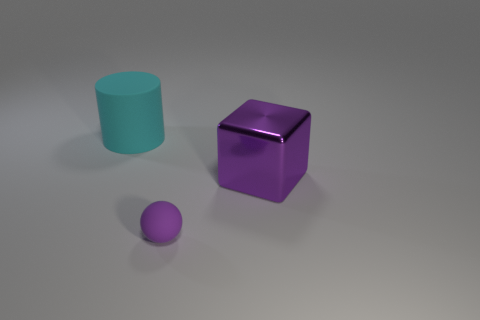Are there any other things that have the same size as the sphere?
Keep it short and to the point. No. What size is the object that is both to the right of the big cyan matte cylinder and behind the tiny purple object?
Your answer should be compact. Large. What size is the matte cylinder?
Give a very brief answer. Large. There is a object that is the same color as the matte sphere; what is its material?
Provide a succinct answer. Metal. Is the small object the same color as the shiny cube?
Your answer should be very brief. Yes. Is the number of small matte balls less than the number of purple rubber cubes?
Keep it short and to the point. No. What material is the purple object behind the sphere?
Give a very brief answer. Metal. What is the material of the cylinder that is the same size as the shiny object?
Make the answer very short. Rubber. What is the material of the large thing that is in front of the rubber thing that is behind the big thing that is on the right side of the tiny purple rubber ball?
Make the answer very short. Metal. Does the cyan thing behind the purple metallic thing have the same size as the small purple matte ball?
Give a very brief answer. No. 